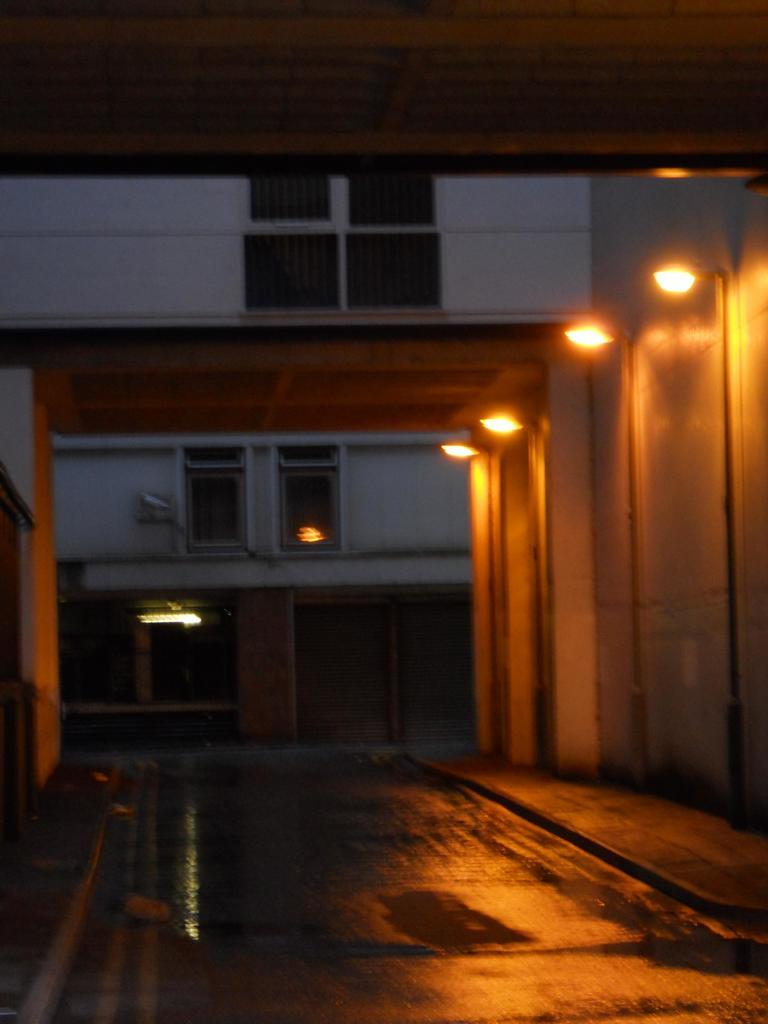What type of structure is present in the image? There is a building in the image. What architectural features can be seen on the building? The building has windows and pillars. What can be seen illuminated in the image? There are lights visible in the image. What type of scissors are being used to control the building's height in the image? There are no scissors present in the image, nor is there any indication that the building's height is being controlled. 